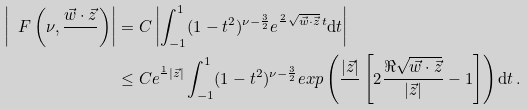Convert formula to latex. <formula><loc_0><loc_0><loc_500><loc_500>\left | \ F \left ( \nu , \frac { \vec { w } \cdot \vec { z } } { } \right ) \right | & = C \left | \int _ { - 1 } ^ { 1 } ( 1 - t ^ { 2 } ) ^ { \nu - \frac { 3 } { 2 } } e ^ { \frac { 2 } { } \sqrt { \vec { w } \cdot \vec { z } } \, t } \mathrm d t \right | \\ & \leq C e ^ { \frac { 1 } { } | \vec { z } | } \int _ { - 1 } ^ { 1 } ( 1 - t ^ { 2 } ) ^ { \nu - \frac { 3 } { 2 } } e x p \left ( { \frac { | \vec { z } | } { } \left [ 2 \frac { \Re \sqrt { \vec { w } \cdot \vec { z } } } { | \vec { z } | } - 1 \right ] } \right ) \mathrm d t \, .</formula> 